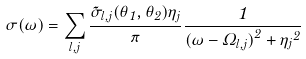<formula> <loc_0><loc_0><loc_500><loc_500>\sigma ( \omega ) = \sum _ { l , j } \frac { { \tilde { \sigma } } _ { l , j } ( \theta _ { 1 } , \theta _ { 2 } ) { \eta _ { j } } } { \pi } \frac { 1 } { { ( \omega - \Omega _ { l , j } ) } ^ { 2 } + { \eta _ { j } } ^ { 2 } }</formula> 